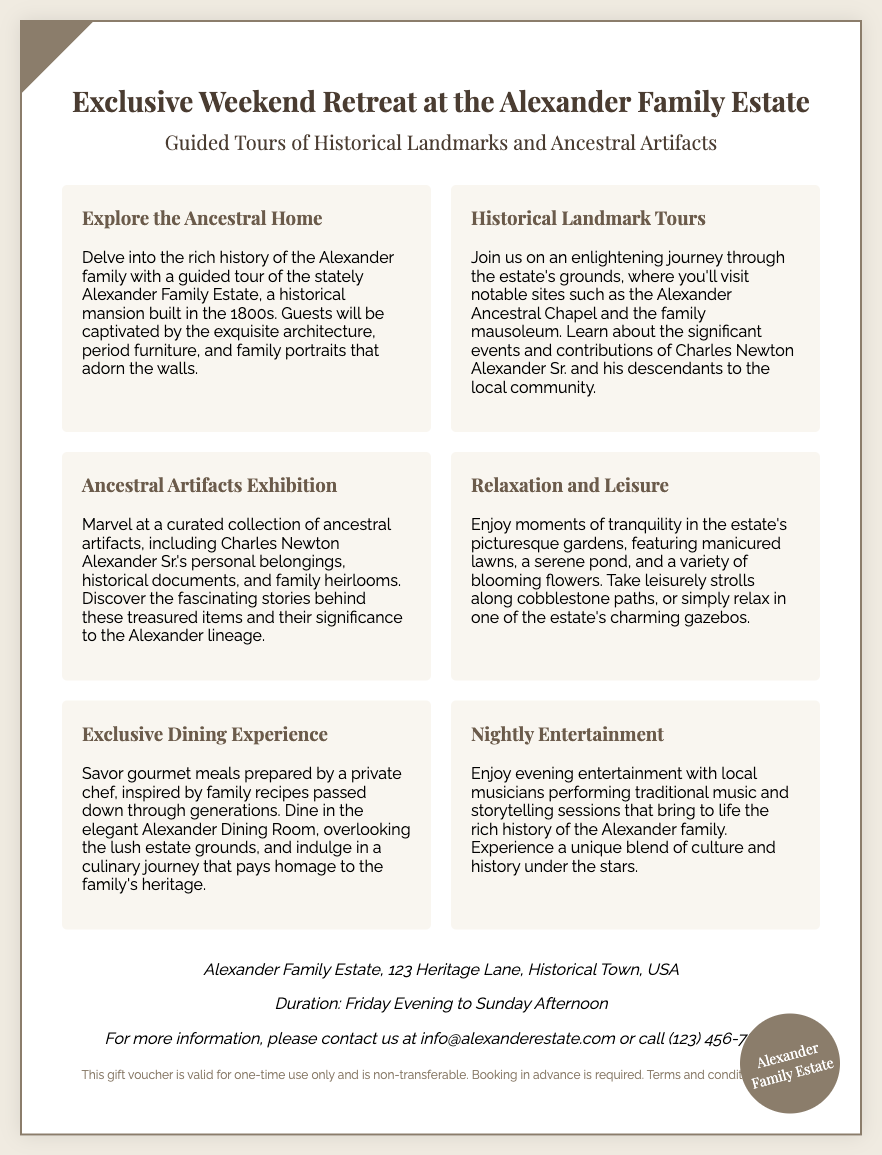What is the title of the gift voucher? The title of the gift voucher is prominently displayed at the top of the document, which is "Exclusive Weekend Retreat at the Alexander Family Estate."
Answer: Exclusive Weekend Retreat at the Alexander Family Estate What is featured in the retreat? The retreat includes guided tours of historical landmarks and ancestral artifacts, as mentioned in the subtitle.
Answer: Guided Tours of Historical Landmarks and Ancestral Artifacts How long is the duration of the retreat? The duration is specified in the additional info section, stating the timeframe from Friday Evening to Sunday Afternoon.
Answer: Friday Evening to Sunday Afternoon What is one of the ancestral artifacts mentioned? The document lists several features, one of which includes Charles Newton Alexander Sr.'s personal belongings.
Answer: Charles Newton Alexander Sr.'s personal belongings What type of experience is promised for dining? The gift voucher mentions savoring gourmet meals prepared by a private chef, indicating an exclusive dining experience.
Answer: Exclusive Dining Experience How many features are listed in the voucher? The features section displays a total of six distinct features related to the weekend retreat experience.
Answer: Six 